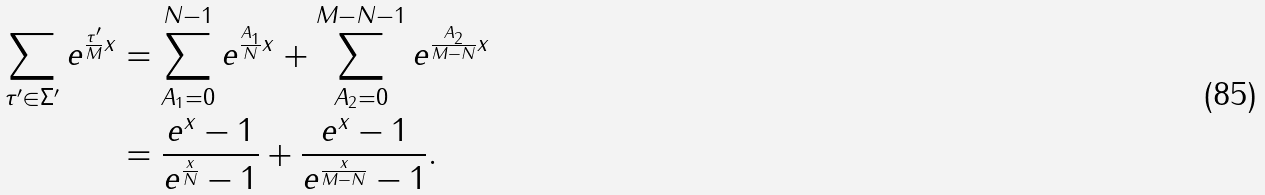Convert formula to latex. <formula><loc_0><loc_0><loc_500><loc_500>\sum _ { \tau ^ { \prime } \in \Sigma ^ { \prime } } e ^ { \frac { \tau ^ { \prime } } { M } x } & = \sum _ { A _ { 1 } = 0 } ^ { N - 1 } e ^ { \frac { A _ { 1 } } { N } x } + \sum _ { A _ { 2 } = 0 } ^ { M - N - 1 } e ^ { \frac { A _ { 2 } } { M - N } x } \\ & = \frac { e ^ { x } - 1 } { e ^ { \frac { x } { N } } - 1 } + \frac { e ^ { x } - 1 } { e ^ { \frac { x } { M - N } } - 1 } .</formula> 